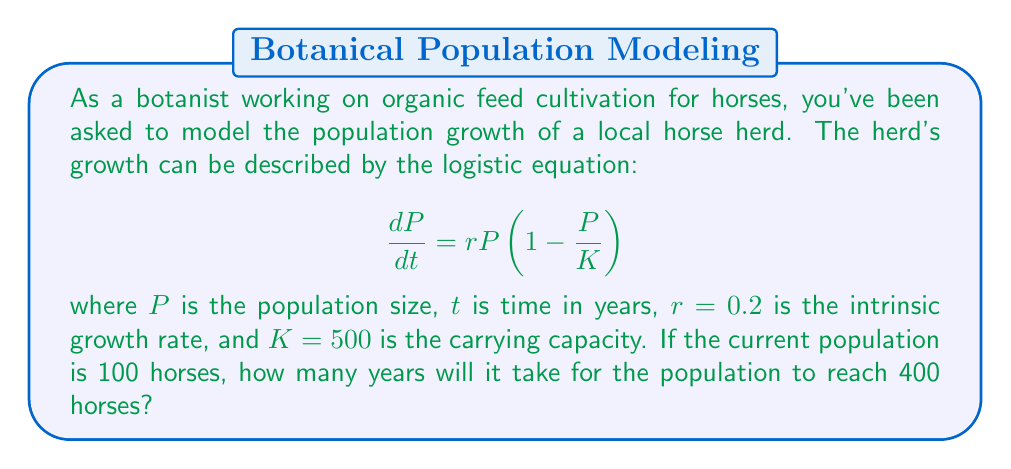Teach me how to tackle this problem. To solve this problem, we need to use the solution to the logistic differential equation:

$$P(t) = \frac{K}{1 + \left(\frac{K}{P_0} - 1\right)e^{-rt}}$$

Where $P_0$ is the initial population size.

Given:
- $K = 500$ (carrying capacity)
- $r = 0.2$ (intrinsic growth rate)
- $P_0 = 100$ (initial population)
- We want to find $t$ when $P(t) = 400$

Step 1: Substitute the known values into the equation:

$$400 = \frac{500}{1 + \left(\frac{500}{100} - 1\right)e^{-0.2t}}$$

Step 2: Simplify:

$$400 = \frac{500}{1 + 4e^{-0.2t}}$$

Step 3: Multiply both sides by $(1 + 4e^{-0.2t})$:

$$400(1 + 4e^{-0.2t}) = 500$$

Step 4: Expand:

$$400 + 1600e^{-0.2t} = 500$$

Step 5: Subtract 400 from both sides:

$$1600e^{-0.2t} = 100$$

Step 6: Divide both sides by 1600:

$$e^{-0.2t} = \frac{1}{16}$$

Step 7: Take the natural logarithm of both sides:

$$-0.2t = \ln\left(\frac{1}{16}\right) = -\ln(16)$$

Step 8: Solve for $t$:

$$t = \frac{\ln(16)}{0.2} \approx 13.86$$

Therefore, it will take approximately 13.86 years for the population to reach 400 horses.
Answer: 13.86 years 